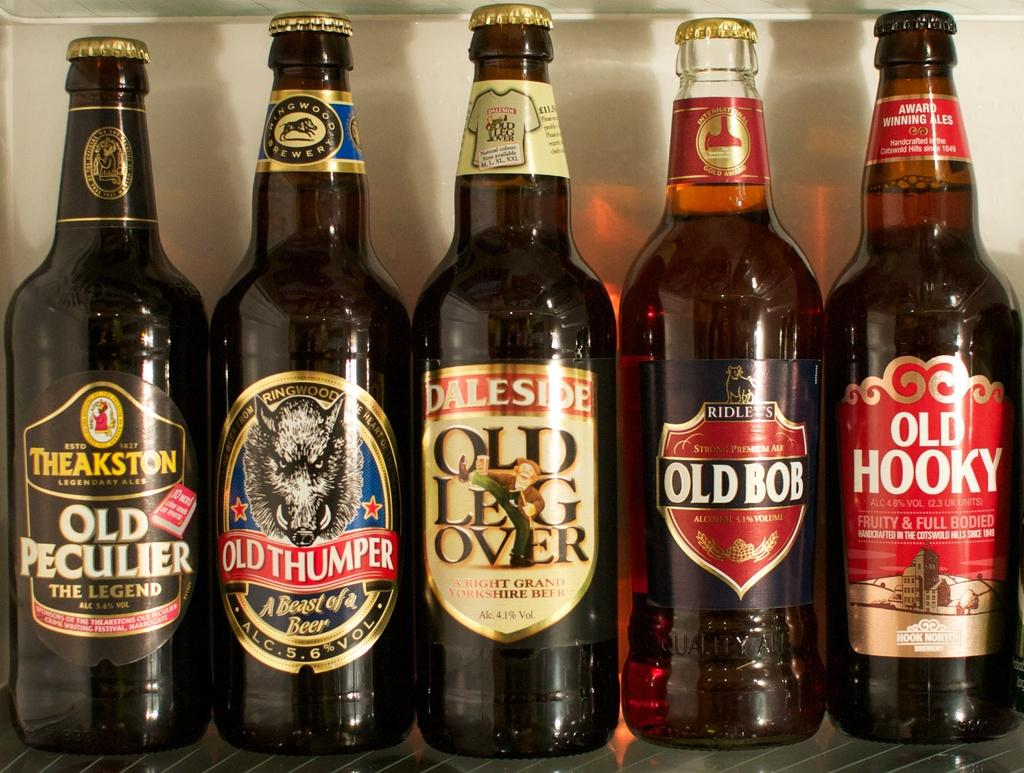<image>
Describe the image concisely. Several bottles of liquor sit on a shelf including Old Bob and Old Hooky. 